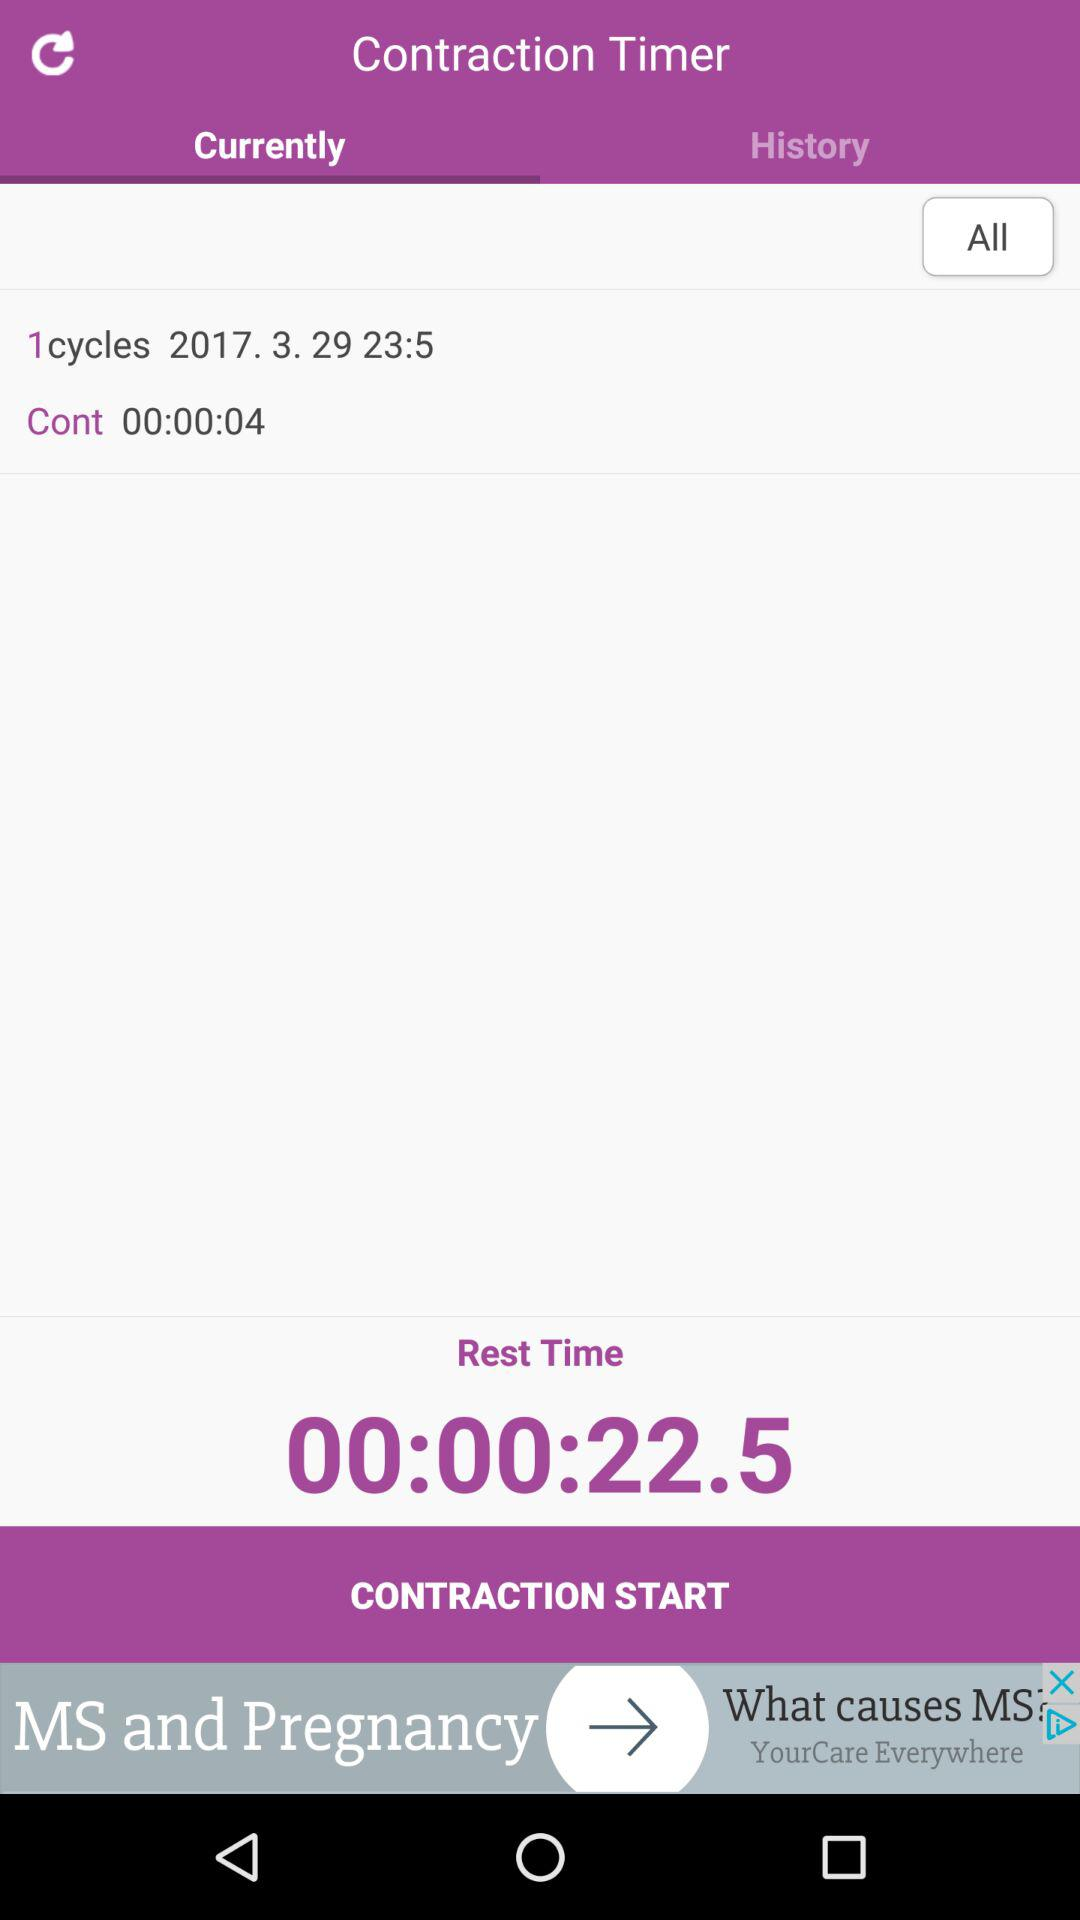How many cycles have been completed?
Answer the question using a single word or phrase. 1 